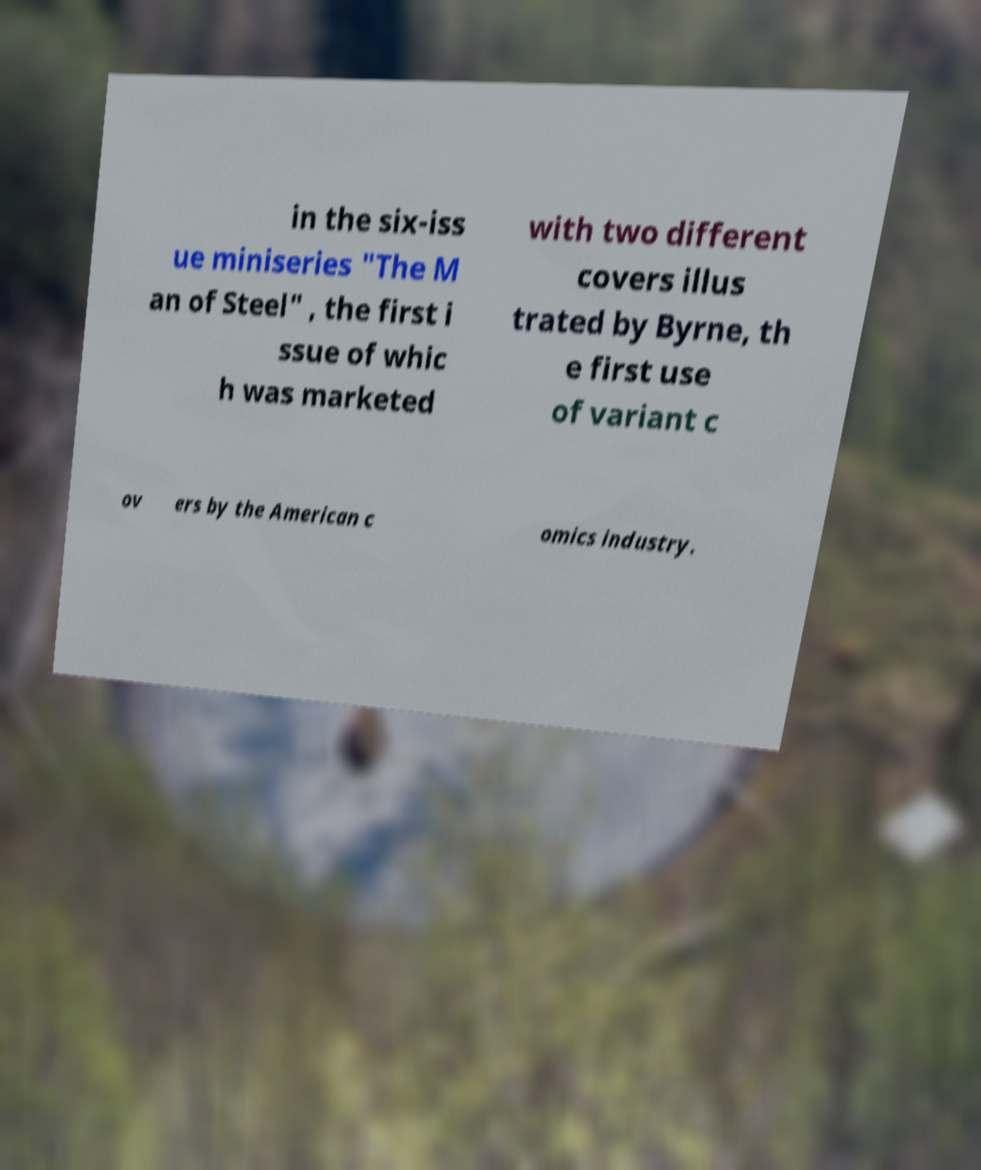Please identify and transcribe the text found in this image. in the six-iss ue miniseries "The M an of Steel" , the first i ssue of whic h was marketed with two different covers illus trated by Byrne, th e first use of variant c ov ers by the American c omics industry. 